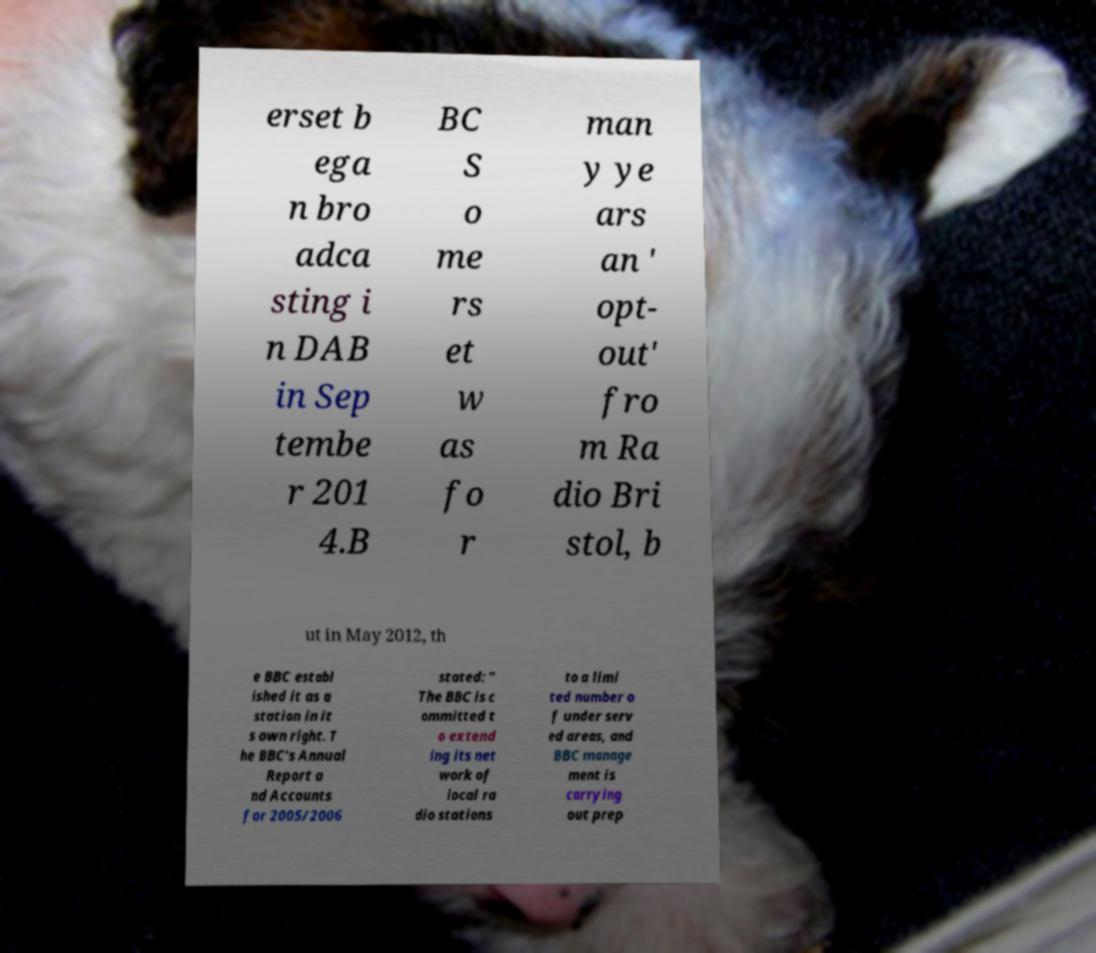Can you read and provide the text displayed in the image?This photo seems to have some interesting text. Can you extract and type it out for me? erset b ega n bro adca sting i n DAB in Sep tembe r 201 4.B BC S o me rs et w as fo r man y ye ars an ' opt- out' fro m Ra dio Bri stol, b ut in May 2012, th e BBC establ ished it as a station in it s own right. T he BBC's Annual Report a nd Accounts for 2005/2006 stated: " The BBC is c ommitted t o extend ing its net work of local ra dio stations to a limi ted number o f under serv ed areas, and BBC manage ment is carrying out prep 